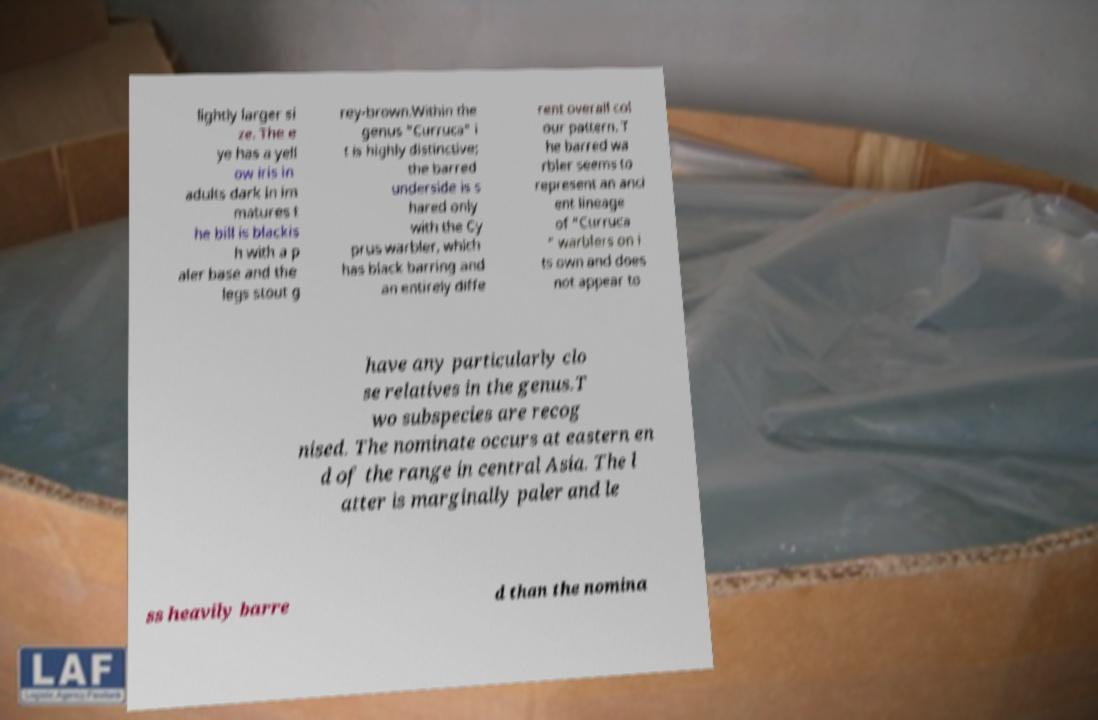I need the written content from this picture converted into text. Can you do that? lightly larger si ze. The e ye has a yell ow iris in adults dark in im matures t he bill is blackis h with a p aler base and the legs stout g rey-brown.Within the genus "Curruca" i t is highly distinctive; the barred underside is s hared only with the Cy prus warbler, which has black barring and an entirely diffe rent overall col our pattern. T he barred wa rbler seems to represent an anci ent lineage of "Curruca " warblers on i ts own and does not appear to have any particularly clo se relatives in the genus.T wo subspecies are recog nised. The nominate occurs at eastern en d of the range in central Asia. The l atter is marginally paler and le ss heavily barre d than the nomina 